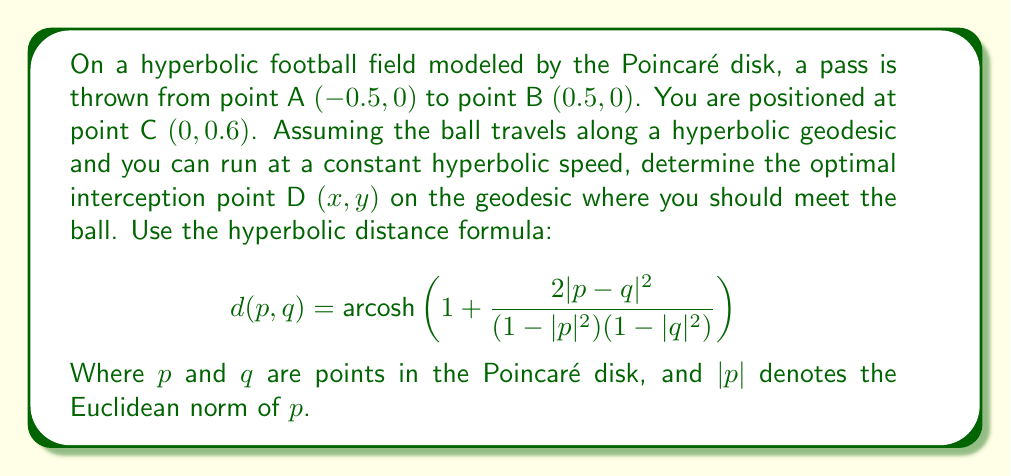Could you help me with this problem? Let's approach this step-by-step:

1) First, we need to find the equation of the geodesic from A to B. In the Poincaré disk model, geodesics are either arcs of circles perpendicular to the boundary circle or diameters. In this case, it's a diameter, so the equation is simply $y = 0$.

2) The optimal interception point D will be where the hyperbolic distances AD and CD are equal. This is because the ball and the player are assumed to move at constant speeds.

3) We can express point D as $(x, 0)$ since it lies on the geodesic $y = 0$.

4) Now, let's set up the equation based on the equality of distances:

   $$d(A,D) = d(C,D)$$

5) Using the hyperbolic distance formula:

   $$\text{arcosh}\left(1 + \frac{2|(x+0.5, 0)|^2}{(1-0.25)(1-x^2)}\right) = \text{arcosh}\left(1 + \frac{2|(x, -0.6)|^2}{(1-0.36)(1-x^2)}\right)$$

6) Simplify:

   $$\text{arcosh}\left(1 + \frac{2(x+0.5)^2}{0.75(1-x^2)}\right) = \text{arcosh}\left(1 + \frac{2(x^2+0.36)}{0.64(1-x^2)}\right)$$

7) Since arcosh is a one-to-one function, we can remove it from both sides:

   $$1 + \frac{2(x+0.5)^2}{0.75(1-x^2)} = 1 + \frac{2(x^2+0.36)}{0.64(1-x^2)}$$

8) Simplify and solve for x:

   $$\frac{2(x+0.5)^2}{0.75} = \frac{2(x^2+0.36)}{0.64}$$
   
   $$1.7067(x+0.5)^2 = 2.0313(x^2+0.36)$$
   
   $$1.7067x^2 + 1.7067x + 0.4267 = 2.0313x^2 + 0.7313$$
   
   $$0.3246x^2 - 1.7067x + 0.3046 = 0$$

9) Solving this quadratic equation gives us $x \approx 0.1891$.

10) Therefore, the optimal interception point D is approximately $(0.1891, 0)$.
Answer: $(0.1891, 0)$ 